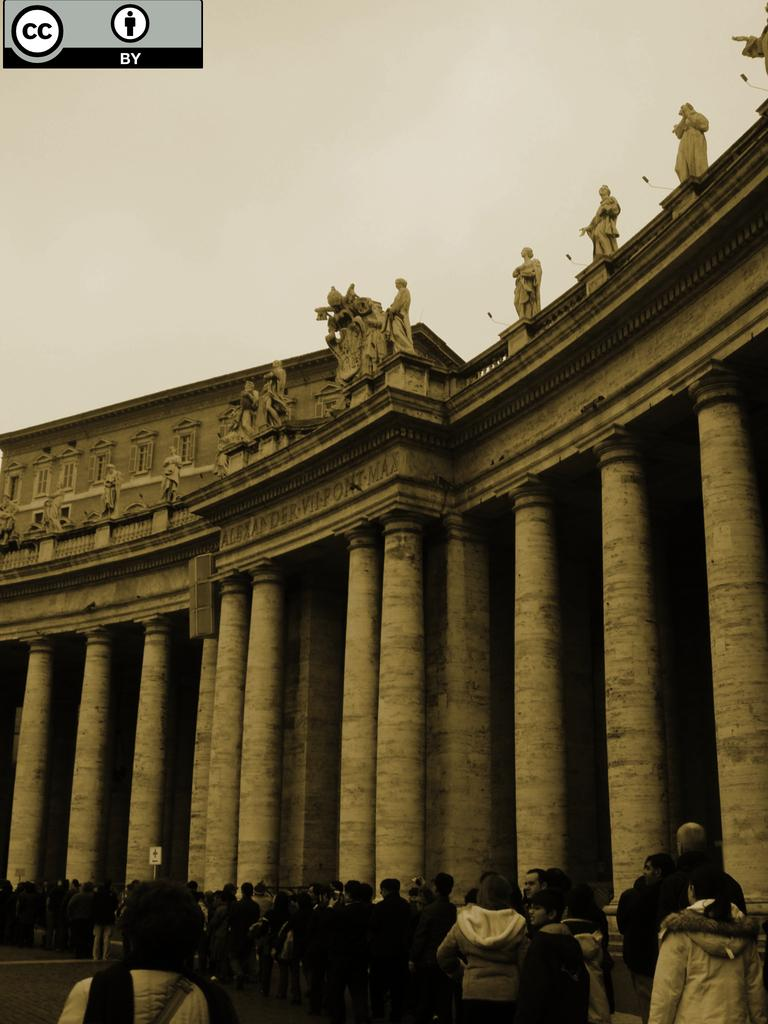What type of structure is visible in the image? There is a building in the image. What else can be seen in the image besides the building? There are people on the road in the image. Can you describe the logo at the top of the image? Unfortunately, the facts provided do not mention any specific details about the logo. How many mice are running across the building in the image? There are no mice present in the image; it only features a building and people on the road. 